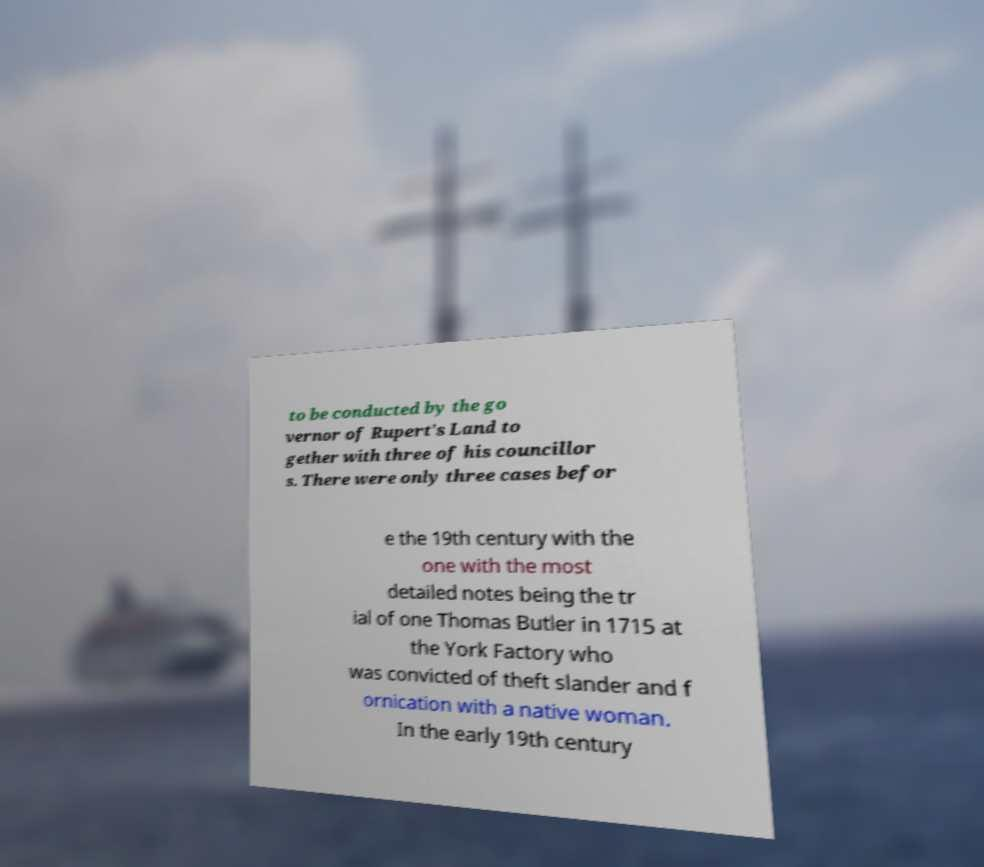What messages or text are displayed in this image? I need them in a readable, typed format. to be conducted by the go vernor of Rupert's Land to gether with three of his councillor s. There were only three cases befor e the 19th century with the one with the most detailed notes being the tr ial of one Thomas Butler in 1715 at the York Factory who was convicted of theft slander and f ornication with a native woman. In the early 19th century 